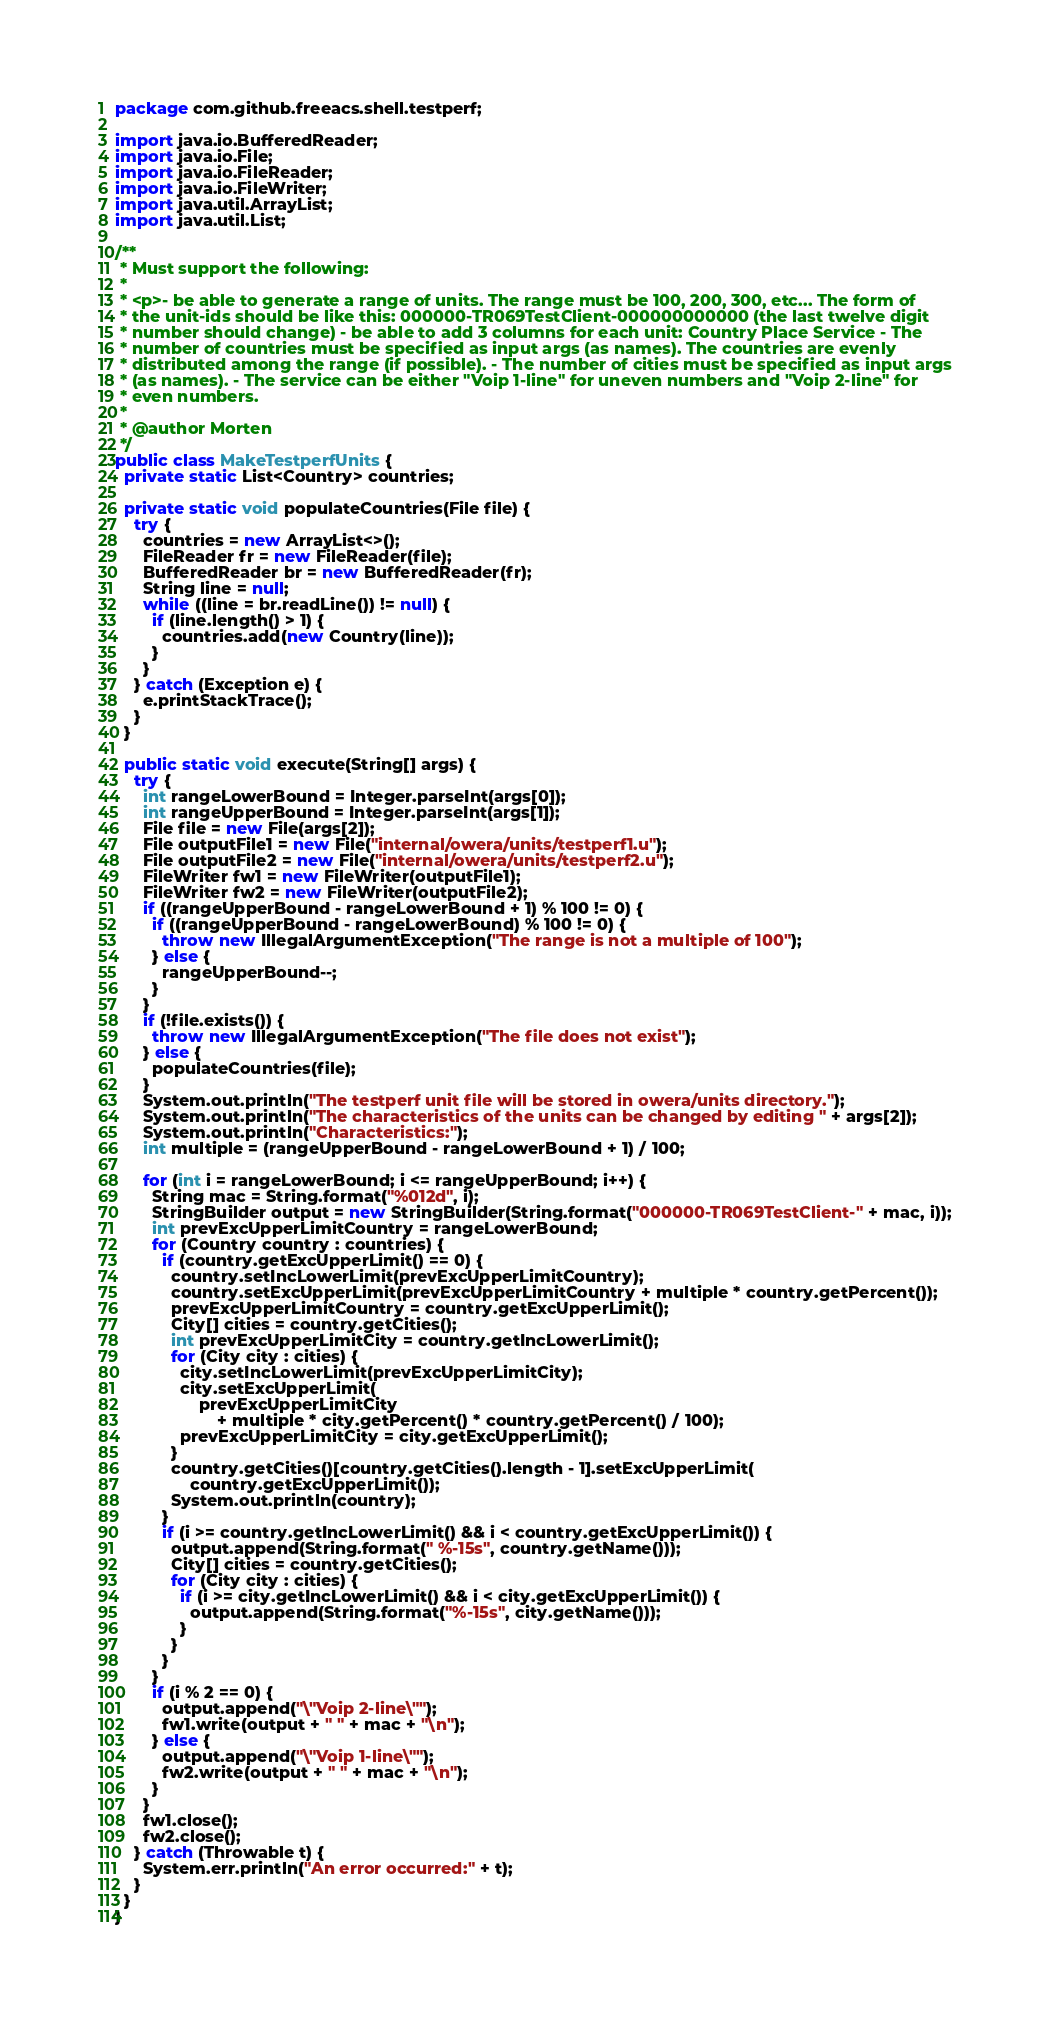<code> <loc_0><loc_0><loc_500><loc_500><_Java_>package com.github.freeacs.shell.testperf;

import java.io.BufferedReader;
import java.io.File;
import java.io.FileReader;
import java.io.FileWriter;
import java.util.ArrayList;
import java.util.List;

/**
 * Must support the following:
 *
 * <p>- be able to generate a range of units. The range must be 100, 200, 300, etc... The form of
 * the unit-ids should be like this: 000000-TR069TestClient-000000000000 (the last twelve digit
 * number should change) - be able to add 3 columns for each unit: Country Place Service - The
 * number of countries must be specified as input args (as names). The countries are evenly
 * distributed among the range (if possible). - The number of cities must be specified as input args
 * (as names). - The service can be either "Voip 1-line" for uneven numbers and "Voip 2-line" for
 * even numbers.
 *
 * @author Morten
 */
public class MakeTestperfUnits {
  private static List<Country> countries;

  private static void populateCountries(File file) {
    try {
      countries = new ArrayList<>();
      FileReader fr = new FileReader(file);
      BufferedReader br = new BufferedReader(fr);
      String line = null;
      while ((line = br.readLine()) != null) {
        if (line.length() > 1) {
          countries.add(new Country(line));
        }
      }
    } catch (Exception e) {
      e.printStackTrace();
    }
  }

  public static void execute(String[] args) {
    try {
      int rangeLowerBound = Integer.parseInt(args[0]);
      int rangeUpperBound = Integer.parseInt(args[1]);
      File file = new File(args[2]);
      File outputFile1 = new File("internal/owera/units/testperf1.u");
      File outputFile2 = new File("internal/owera/units/testperf2.u");
      FileWriter fw1 = new FileWriter(outputFile1);
      FileWriter fw2 = new FileWriter(outputFile2);
      if ((rangeUpperBound - rangeLowerBound + 1) % 100 != 0) {
        if ((rangeUpperBound - rangeLowerBound) % 100 != 0) {
          throw new IllegalArgumentException("The range is not a multiple of 100");
        } else {
          rangeUpperBound--;
        }
      }
      if (!file.exists()) {
        throw new IllegalArgumentException("The file does not exist");
      } else {
        populateCountries(file);
      }
      System.out.println("The testperf unit file will be stored in owera/units directory.");
      System.out.println("The characteristics of the units can be changed by editing " + args[2]);
      System.out.println("Characteristics:");
      int multiple = (rangeUpperBound - rangeLowerBound + 1) / 100;

      for (int i = rangeLowerBound; i <= rangeUpperBound; i++) {
        String mac = String.format("%012d", i);
        StringBuilder output = new StringBuilder(String.format("000000-TR069TestClient-" + mac, i));
        int prevExcUpperLimitCountry = rangeLowerBound;
        for (Country country : countries) {
          if (country.getExcUpperLimit() == 0) {
            country.setIncLowerLimit(prevExcUpperLimitCountry);
            country.setExcUpperLimit(prevExcUpperLimitCountry + multiple * country.getPercent());
            prevExcUpperLimitCountry = country.getExcUpperLimit();
            City[] cities = country.getCities();
            int prevExcUpperLimitCity = country.getIncLowerLimit();
            for (City city : cities) {
              city.setIncLowerLimit(prevExcUpperLimitCity);
              city.setExcUpperLimit(
                  prevExcUpperLimitCity
                      + multiple * city.getPercent() * country.getPercent() / 100);
              prevExcUpperLimitCity = city.getExcUpperLimit();
            }
            country.getCities()[country.getCities().length - 1].setExcUpperLimit(
                country.getExcUpperLimit());
            System.out.println(country);
          }
          if (i >= country.getIncLowerLimit() && i < country.getExcUpperLimit()) {
            output.append(String.format(" %-15s", country.getName()));
            City[] cities = country.getCities();
            for (City city : cities) {
              if (i >= city.getIncLowerLimit() && i < city.getExcUpperLimit()) {
                output.append(String.format("%-15s", city.getName()));
              }
            }
          }
        }
        if (i % 2 == 0) {
          output.append("\"Voip 2-line\"");
          fw1.write(output + " " + mac + "\n");
        } else {
          output.append("\"Voip 1-line\"");
          fw2.write(output + " " + mac + "\n");
        }
      }
      fw1.close();
      fw2.close();
    } catch (Throwable t) {
      System.err.println("An error occurred:" + t);
    }
  }
}
</code> 